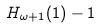<formula> <loc_0><loc_0><loc_500><loc_500>H _ { \omega + 1 } ( 1 ) - 1</formula> 